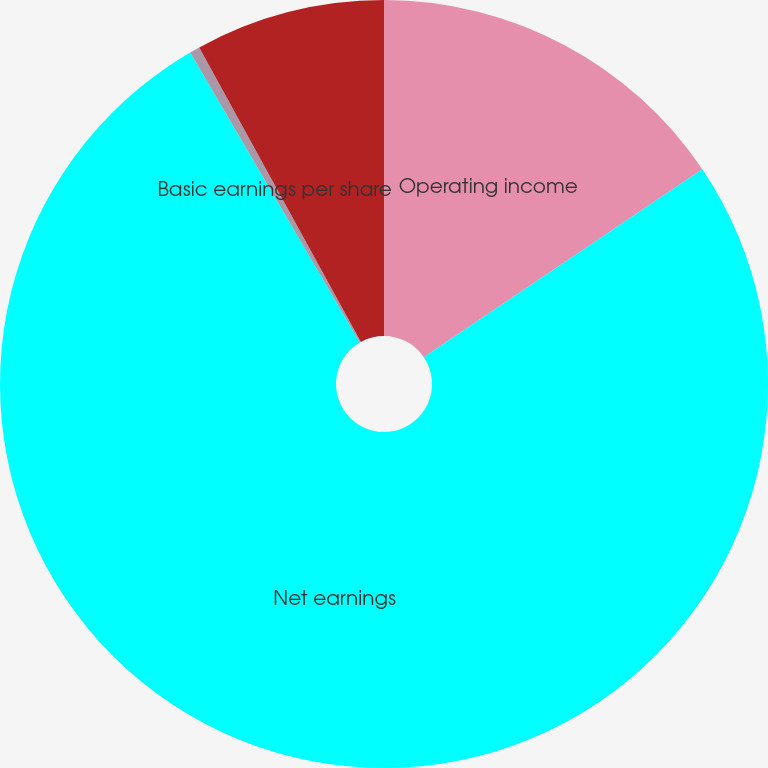Convert chart to OTSL. <chart><loc_0><loc_0><loc_500><loc_500><pie_chart><fcel>Operating income<fcel>Net earnings<fcel>Basic earnings per share<fcel>Diluted earnings per share<nl><fcel>15.55%<fcel>76.03%<fcel>0.43%<fcel>7.99%<nl></chart> 